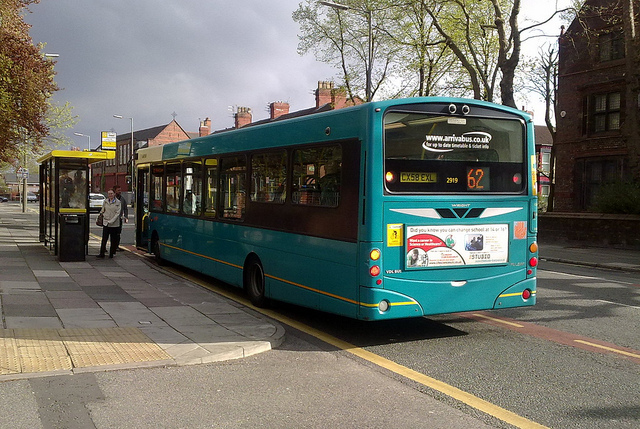Please transcribe the text in this image. 62 EXL 